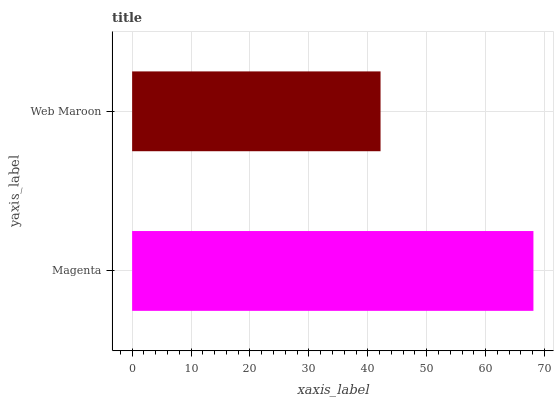Is Web Maroon the minimum?
Answer yes or no. Yes. Is Magenta the maximum?
Answer yes or no. Yes. Is Web Maroon the maximum?
Answer yes or no. No. Is Magenta greater than Web Maroon?
Answer yes or no. Yes. Is Web Maroon less than Magenta?
Answer yes or no. Yes. Is Web Maroon greater than Magenta?
Answer yes or no. No. Is Magenta less than Web Maroon?
Answer yes or no. No. Is Magenta the high median?
Answer yes or no. Yes. Is Web Maroon the low median?
Answer yes or no. Yes. Is Web Maroon the high median?
Answer yes or no. No. Is Magenta the low median?
Answer yes or no. No. 